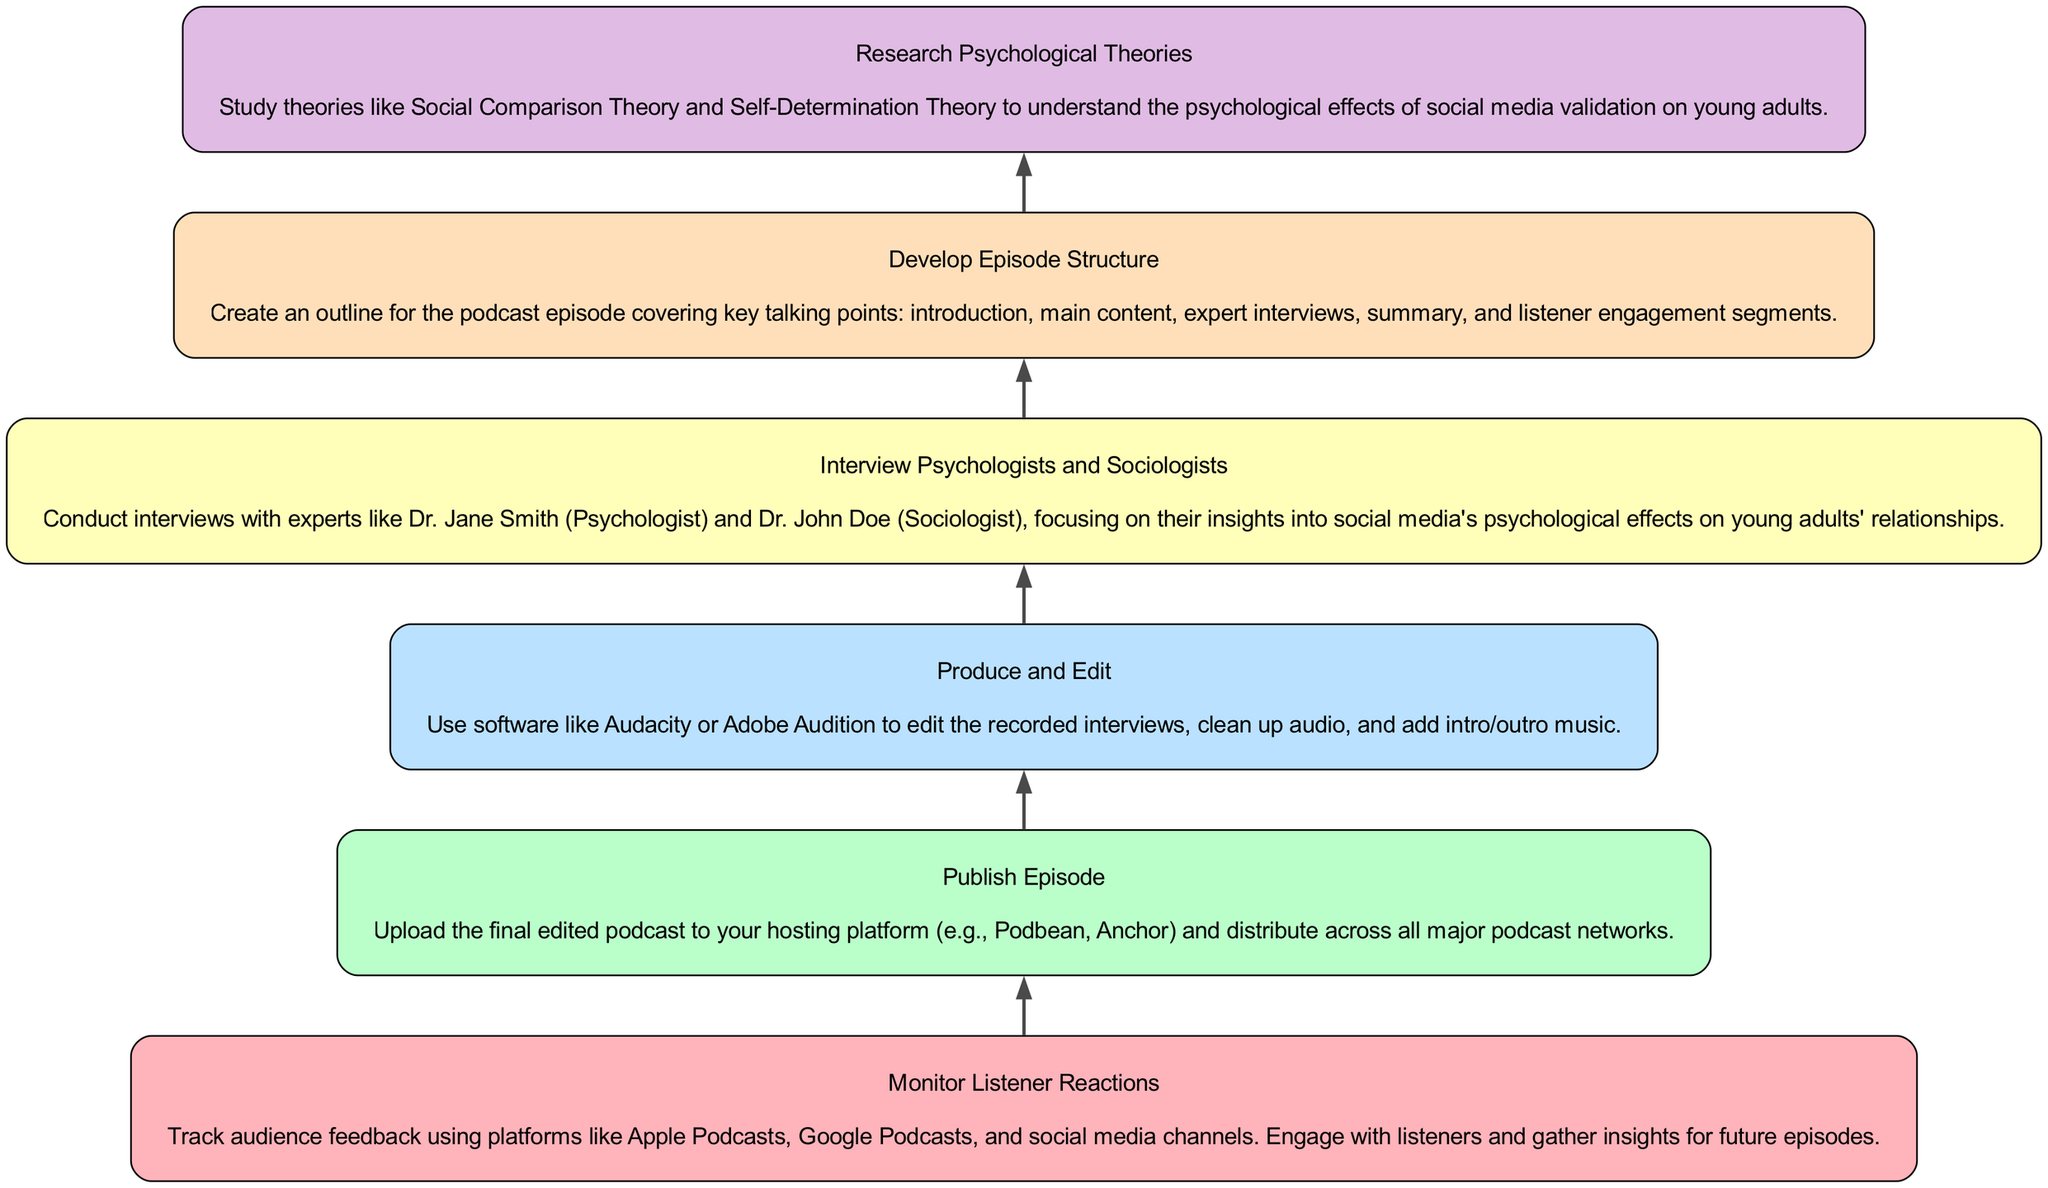What is the first step in the flowchart? The flowchart starts at the bottom with "Research Psychological Theories," which is the first action required before proceeding to further steps in the podcast production process.
Answer: Research Psychological Theories How many elements are in the flowchart? By counting the nodes in the diagram, there are a total of six elements depicted as steps in the process of creating the podcast.
Answer: Six What connects the "Develop Episode Structure" and "Interview Psychologists and Sociologists"? The connection shows the sequence of steps in the podcast creation; "Develop Episode Structure" leads into "Interview Psychologists and Sociologists," indicating that structuring the episode occurs before interviews are conducted.
Answer: An edge What is the last node of the flowchart? The final step in the process depicted is "Monitor Listener Reactions," which indicates the last action taken after the episode is published.
Answer: Monitor Listener Reactions What is the purpose of the "Produce and Edit" step? This step involves using software to refine the quality of the recorded content, ensuring it is polished and suitable for listeners before publishing.
Answer: Editing How does the "Interview Psychologists and Sociologists" contribute to understanding social media's effects? This step gathers expert insights that are crucial for discussing the psychological effects of social media validation in young adults' relationships, providing depth and credibility to the episode content.
Answer: Provides expert insights What is the relationship between "Publish Episode" and "Monitor Listener Reactions"? "Publish Episode" is the action taken before "Monitor Listener Reactions," establishing a sequential relationship where publishing occurs first, followed by monitoring the listener's feedback.
Answer: Sequential steps What type of feedback is gathered in "Monitor Listener Reactions"? This step involves tracking audience feedback specifically from various podcast platforms and social media, focusing on engagement and insights for future episodes.
Answer: Audience feedback What are the key elements included in the "Develop Episode Structure"? The episode outline includes critical talking points that structure the podcast, such as introduction, main content, expert interviews, summary, and listener engagement.
Answer: Key talking points 